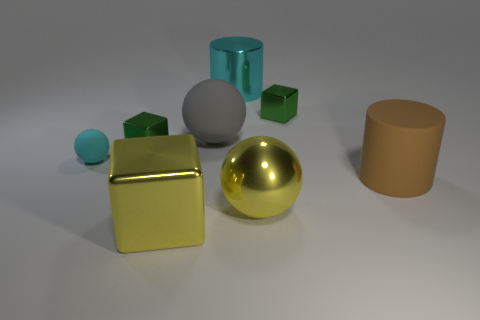There is a shiny object that is the same color as the tiny ball; what shape is it? cylinder 